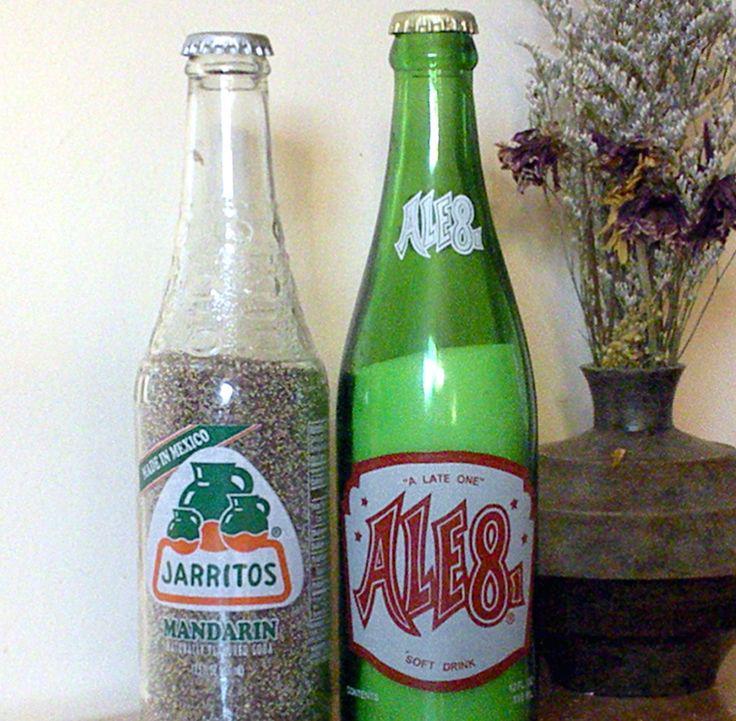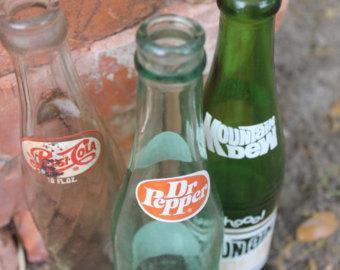The first image is the image on the left, the second image is the image on the right. Considering the images on both sides, is "The right image includes multiple bottles with the same red-and-white labels, while the left image contains no identical bottles." valid? Answer yes or no. No. The first image is the image on the left, the second image is the image on the right. Considering the images on both sides, is "The right image contains exactly two bottles." valid? Answer yes or no. No. 